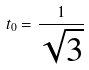Convert formula to latex. <formula><loc_0><loc_0><loc_500><loc_500>t _ { 0 } = \frac { 1 } { \sqrt { 3 } }</formula> 